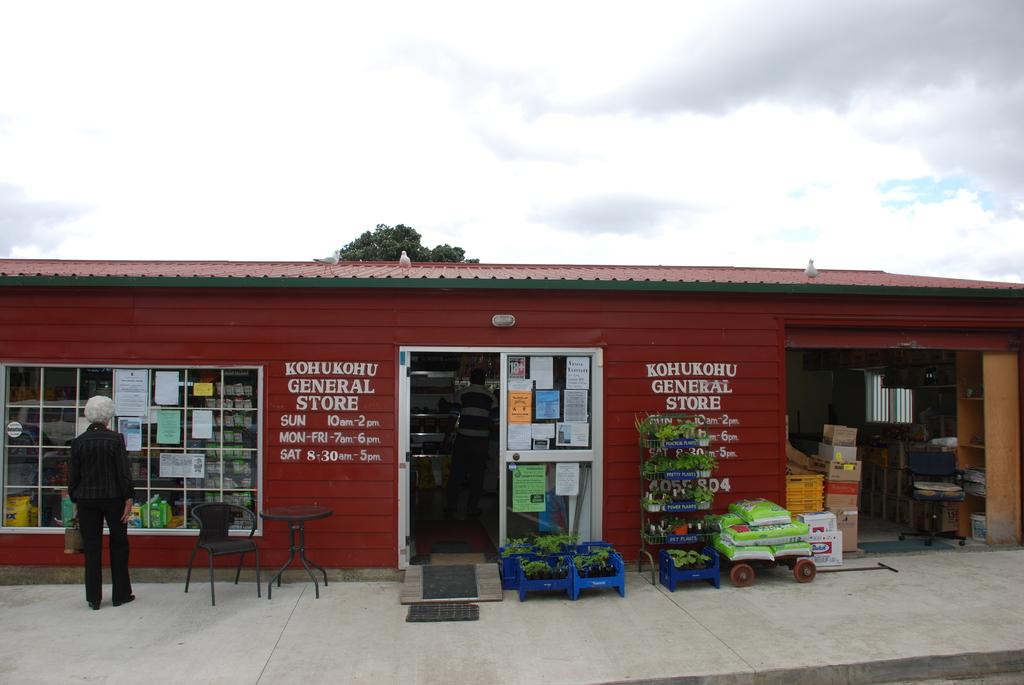What time does this store open on saturdays?
Offer a very short reply. 8:30. What kind of store is this?
Provide a short and direct response. General store. 